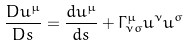Convert formula to latex. <formula><loc_0><loc_0><loc_500><loc_500>\frac { D u ^ { \mu } } { D s } = \frac { d u ^ { \mu } } { d s } + \Gamma ^ { \mu } _ { \nu \sigma } u ^ { \nu } u ^ { \sigma }</formula> 